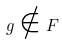<formula> <loc_0><loc_0><loc_500><loc_500>g \notin F</formula> 